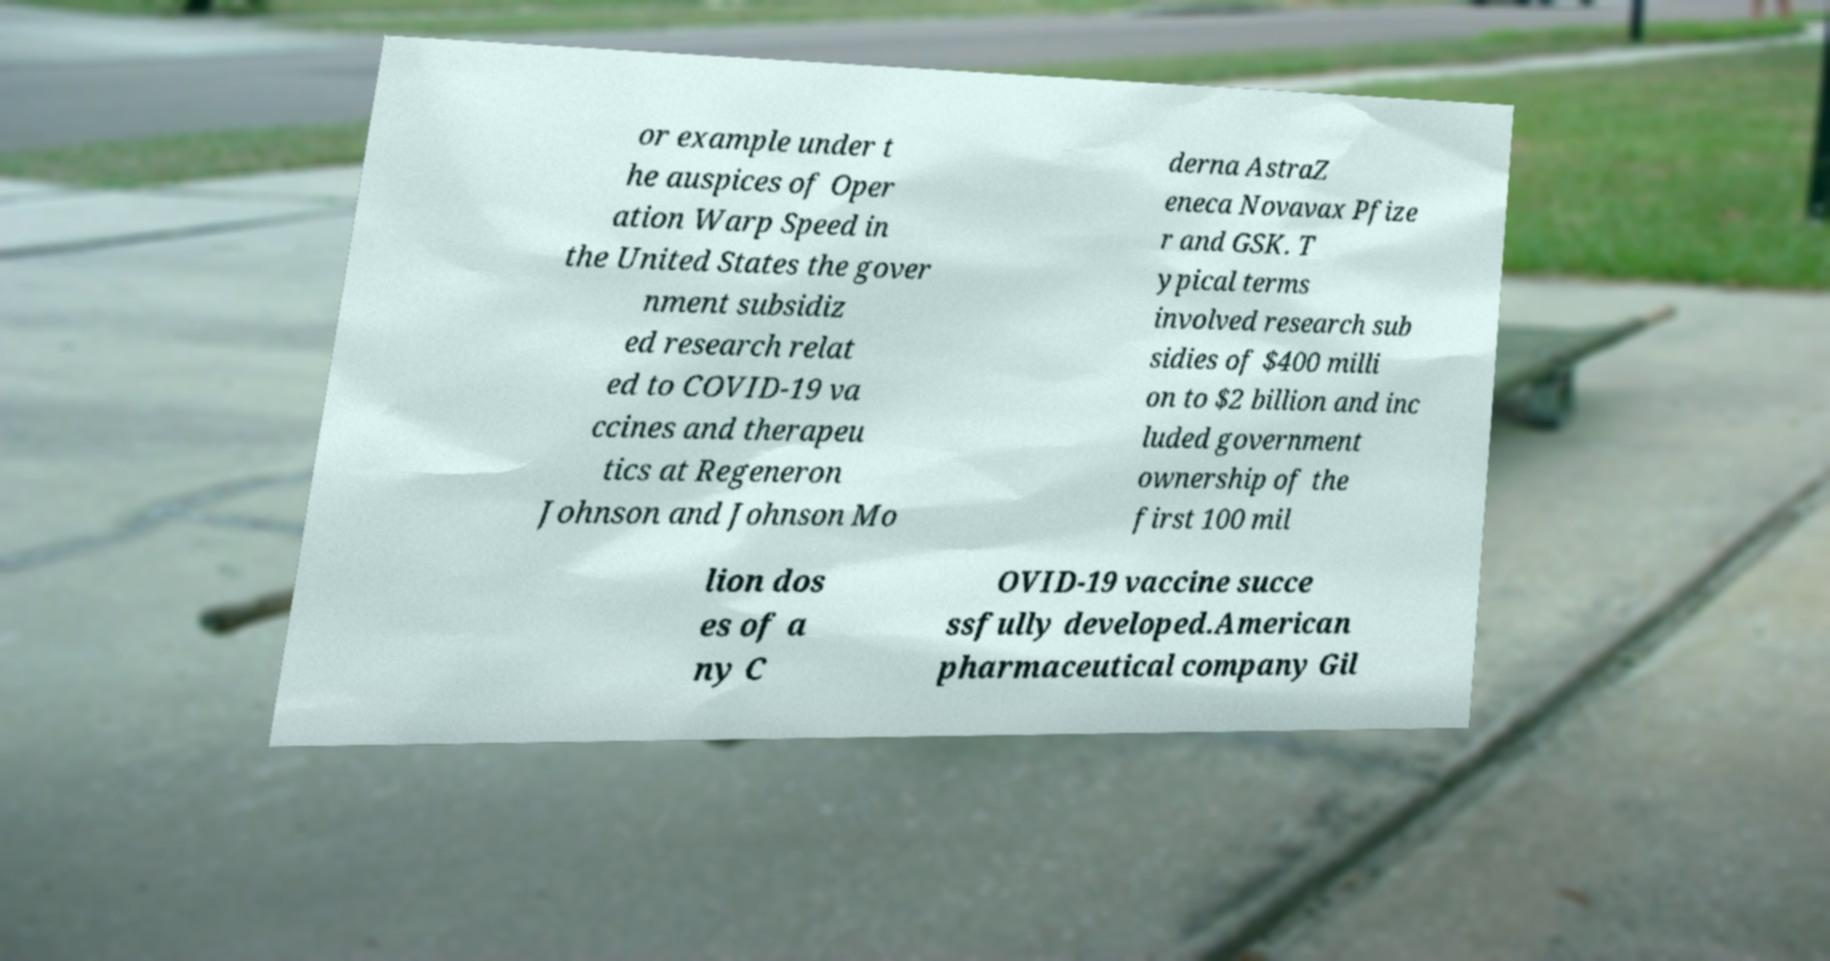Please read and relay the text visible in this image. What does it say? or example under t he auspices of Oper ation Warp Speed in the United States the gover nment subsidiz ed research relat ed to COVID-19 va ccines and therapeu tics at Regeneron Johnson and Johnson Mo derna AstraZ eneca Novavax Pfize r and GSK. T ypical terms involved research sub sidies of $400 milli on to $2 billion and inc luded government ownership of the first 100 mil lion dos es of a ny C OVID-19 vaccine succe ssfully developed.American pharmaceutical company Gil 